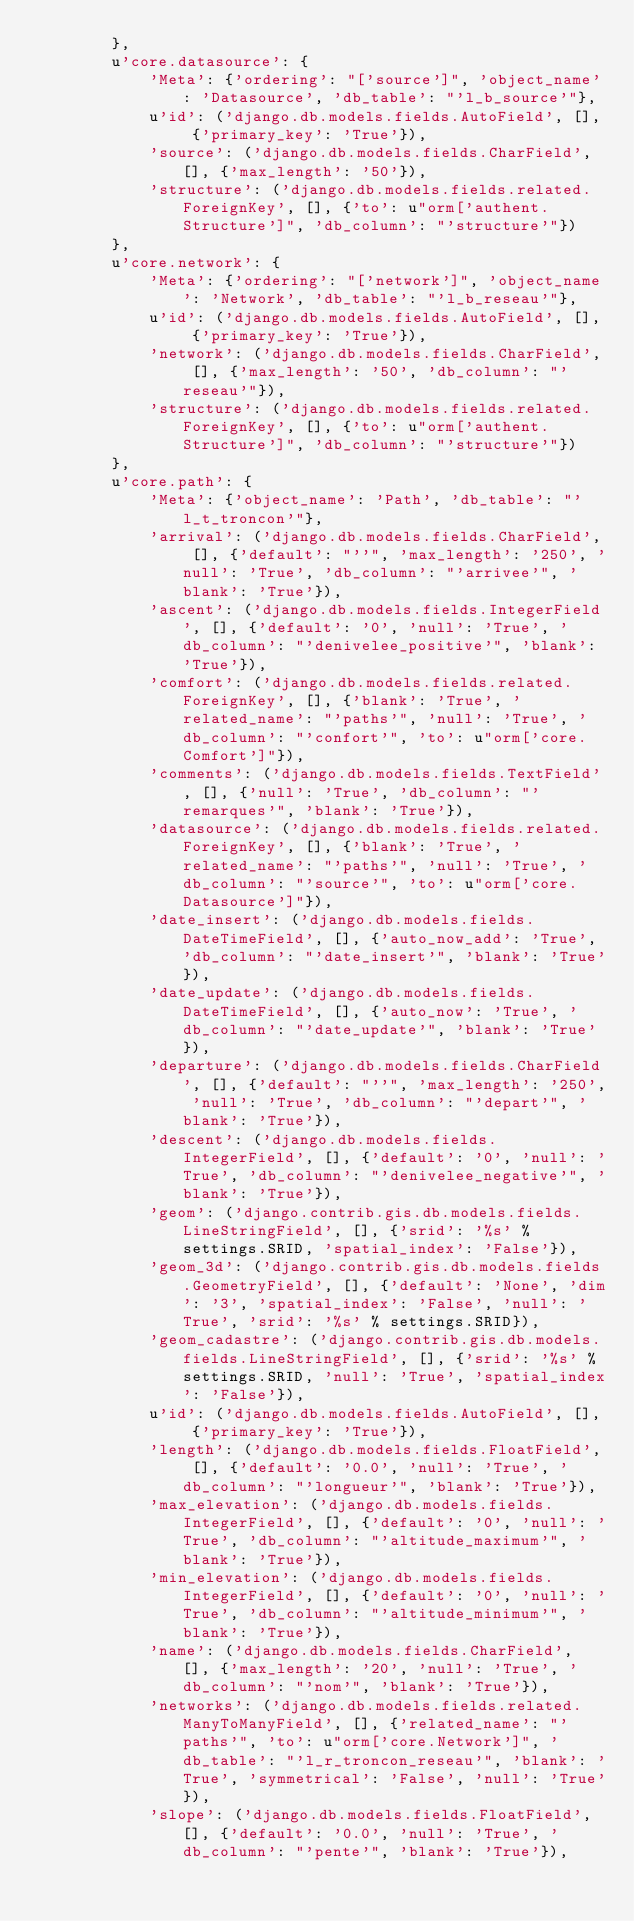<code> <loc_0><loc_0><loc_500><loc_500><_Python_>        },
        u'core.datasource': {
            'Meta': {'ordering': "['source']", 'object_name': 'Datasource', 'db_table': "'l_b_source'"},
            u'id': ('django.db.models.fields.AutoField', [], {'primary_key': 'True'}),
            'source': ('django.db.models.fields.CharField', [], {'max_length': '50'}),
            'structure': ('django.db.models.fields.related.ForeignKey', [], {'to': u"orm['authent.Structure']", 'db_column': "'structure'"})
        },
        u'core.network': {
            'Meta': {'ordering': "['network']", 'object_name': 'Network', 'db_table': "'l_b_reseau'"},
            u'id': ('django.db.models.fields.AutoField', [], {'primary_key': 'True'}),
            'network': ('django.db.models.fields.CharField', [], {'max_length': '50', 'db_column': "'reseau'"}),
            'structure': ('django.db.models.fields.related.ForeignKey', [], {'to': u"orm['authent.Structure']", 'db_column': "'structure'"})
        },
        u'core.path': {
            'Meta': {'object_name': 'Path', 'db_table': "'l_t_troncon'"},
            'arrival': ('django.db.models.fields.CharField', [], {'default': "''", 'max_length': '250', 'null': 'True', 'db_column': "'arrivee'", 'blank': 'True'}),
            'ascent': ('django.db.models.fields.IntegerField', [], {'default': '0', 'null': 'True', 'db_column': "'denivelee_positive'", 'blank': 'True'}),
            'comfort': ('django.db.models.fields.related.ForeignKey', [], {'blank': 'True', 'related_name': "'paths'", 'null': 'True', 'db_column': "'confort'", 'to': u"orm['core.Comfort']"}),
            'comments': ('django.db.models.fields.TextField', [], {'null': 'True', 'db_column': "'remarques'", 'blank': 'True'}),
            'datasource': ('django.db.models.fields.related.ForeignKey', [], {'blank': 'True', 'related_name': "'paths'", 'null': 'True', 'db_column': "'source'", 'to': u"orm['core.Datasource']"}),
            'date_insert': ('django.db.models.fields.DateTimeField', [], {'auto_now_add': 'True', 'db_column': "'date_insert'", 'blank': 'True'}),
            'date_update': ('django.db.models.fields.DateTimeField', [], {'auto_now': 'True', 'db_column': "'date_update'", 'blank': 'True'}),
            'departure': ('django.db.models.fields.CharField', [], {'default': "''", 'max_length': '250', 'null': 'True', 'db_column': "'depart'", 'blank': 'True'}),
            'descent': ('django.db.models.fields.IntegerField', [], {'default': '0', 'null': 'True', 'db_column': "'denivelee_negative'", 'blank': 'True'}),
            'geom': ('django.contrib.gis.db.models.fields.LineStringField', [], {'srid': '%s' % settings.SRID, 'spatial_index': 'False'}),
            'geom_3d': ('django.contrib.gis.db.models.fields.GeometryField', [], {'default': 'None', 'dim': '3', 'spatial_index': 'False', 'null': 'True', 'srid': '%s' % settings.SRID}),
            'geom_cadastre': ('django.contrib.gis.db.models.fields.LineStringField', [], {'srid': '%s' % settings.SRID, 'null': 'True', 'spatial_index': 'False'}),
            u'id': ('django.db.models.fields.AutoField', [], {'primary_key': 'True'}),
            'length': ('django.db.models.fields.FloatField', [], {'default': '0.0', 'null': 'True', 'db_column': "'longueur'", 'blank': 'True'}),
            'max_elevation': ('django.db.models.fields.IntegerField', [], {'default': '0', 'null': 'True', 'db_column': "'altitude_maximum'", 'blank': 'True'}),
            'min_elevation': ('django.db.models.fields.IntegerField', [], {'default': '0', 'null': 'True', 'db_column': "'altitude_minimum'", 'blank': 'True'}),
            'name': ('django.db.models.fields.CharField', [], {'max_length': '20', 'null': 'True', 'db_column': "'nom'", 'blank': 'True'}),
            'networks': ('django.db.models.fields.related.ManyToManyField', [], {'related_name': "'paths'", 'to': u"orm['core.Network']", 'db_table': "'l_r_troncon_reseau'", 'blank': 'True', 'symmetrical': 'False', 'null': 'True'}),
            'slope': ('django.db.models.fields.FloatField', [], {'default': '0.0', 'null': 'True', 'db_column': "'pente'", 'blank': 'True'}),</code> 